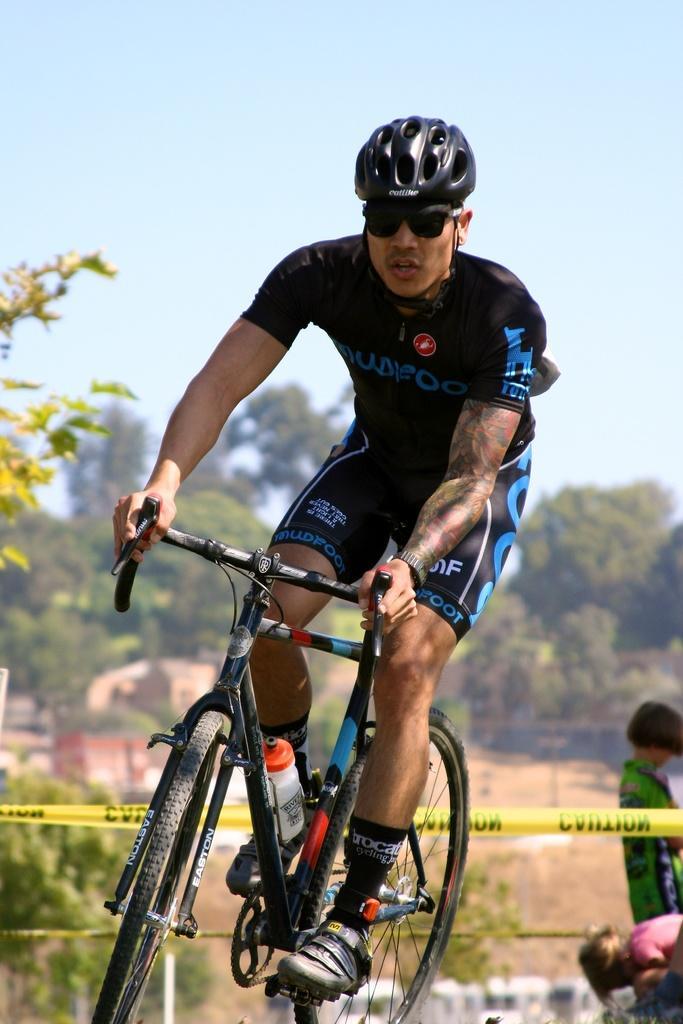Can you describe this image briefly? This is a picture of a man cycling, he is wearing a black dress. In the background there are trees. To the right there are kids playing. Sky is clear and sunny. 